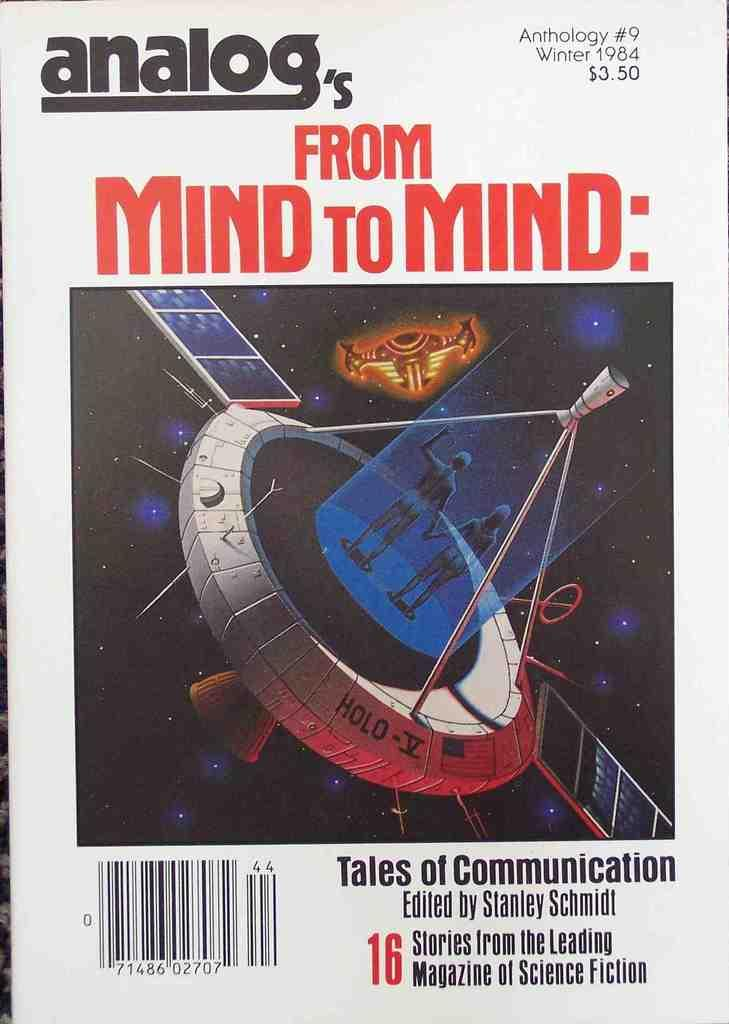<image>
Give a short and clear explanation of the subsequent image. A poster of Analog's from Mind to Mind with a satellite on it. 